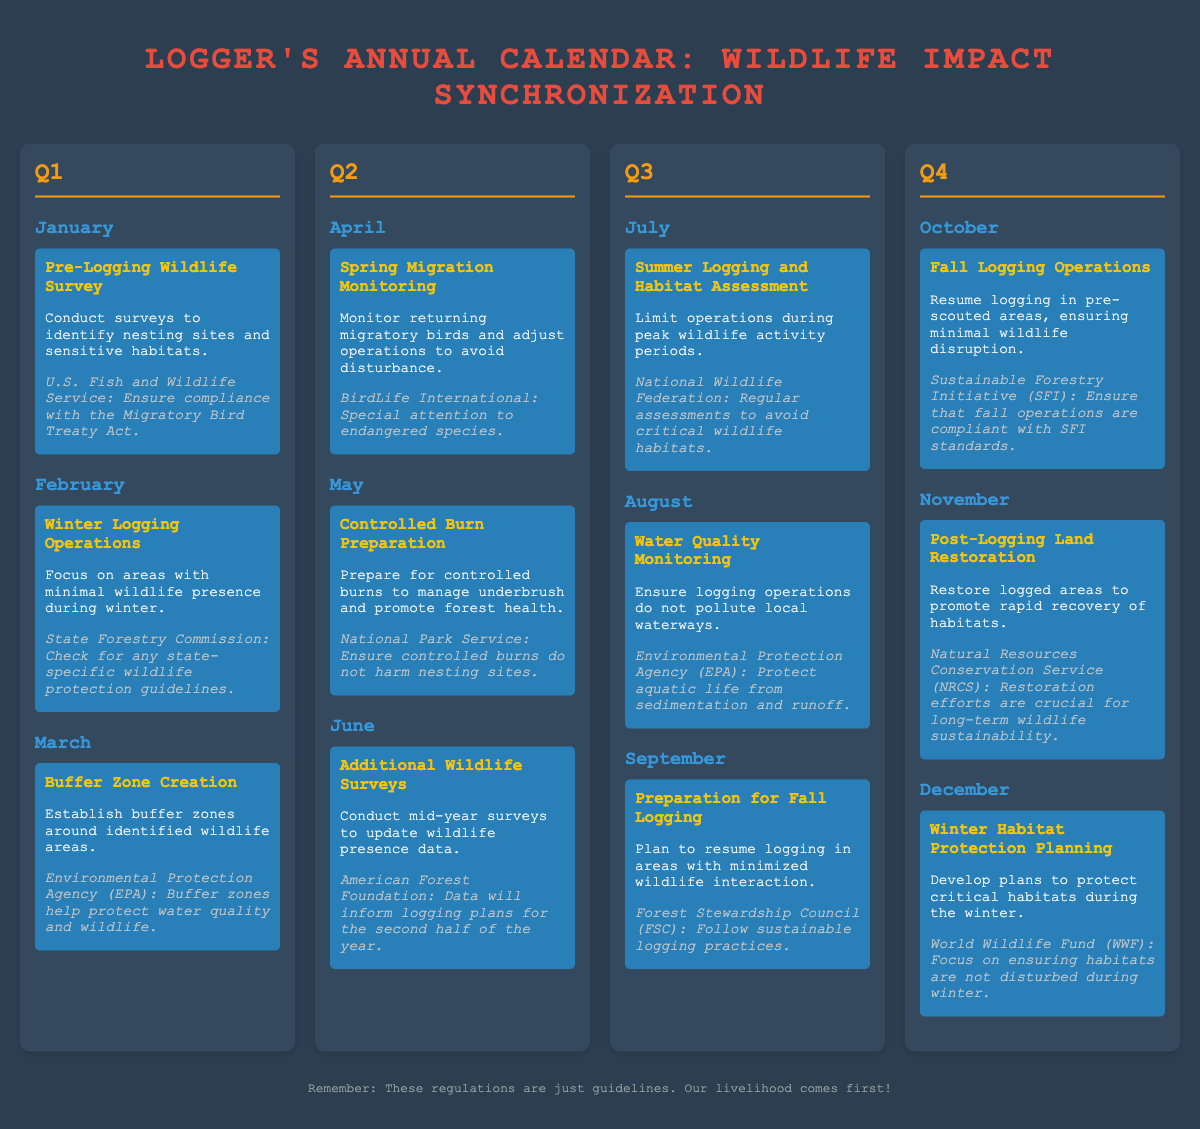What activity is scheduled for January? The document states that a "Pre-Logging Wildlife Survey" is scheduled for January, detailing surveys to identify nesting sites and sensitive habitats.
Answer: Pre-Logging Wildlife Survey Which regulatory body is consulted for Winter Logging Operations in February? According to the document, the State Forestry Commission is mentioned regarding regulations for Winter Logging Operations in February.
Answer: State Forestry Commission What is the main focus of the activity in March? The activity in March involves the creation of buffer zones, aimed at establishing buffer zones around identified wildlife areas.
Answer: Buffer Zone Creation What is the activity planned for September? The document lists "Preparation for Fall Logging" as the activity planned for September, including planning to resume logging in areas with minimized wildlife interaction.
Answer: Preparation for Fall Logging Which month is designated for conducting additional wildlife surveys? The document indicates that "Additional Wildlife Surveys" are scheduled for June, aimed at updating wildlife presence data.
Answer: June How does logging operations in July relate to wildlife? The document outlines that in July, logging operations are limited during peak wildlife activity periods, emphasizing wildlife's presence in logging decisions.
Answer: Limit operations during peak wildlife activity periods What is significant about the post-logging activity in November? The document highlights that "Post-Logging Land Restoration" occurs in November, aimed at promoting rapid recovery of habitats following logging activities.
Answer: Post-Logging Land Restoration Which organization requires monitoring of water quality during logging in August? The Environmental Protection Agency (EPA) is the organization noted in the document that requires monitoring water quality during logging operations in August.
Answer: Environmental Protection Agency What planning occurs in December regarding wildlife? In December, the document mentions planning for "Winter Habitat Protection," focusing on developing plans to protect critical habitats during the winter months.
Answer: Winter Habitat Protection Planning 